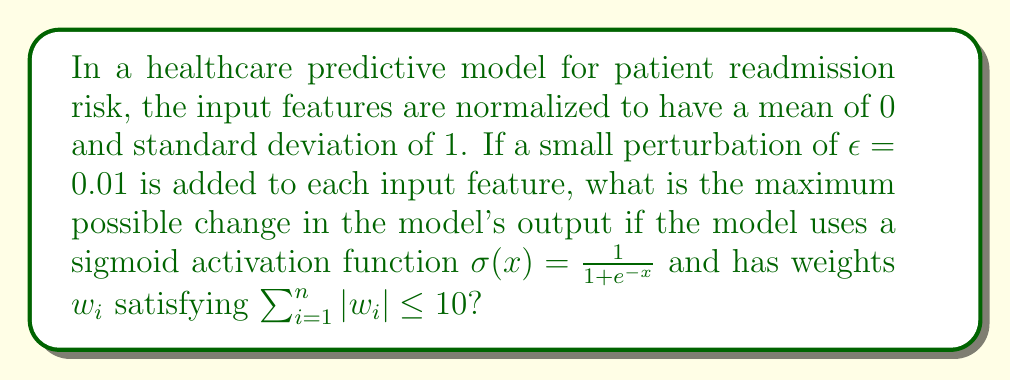Help me with this question. Let's approach this step-by-step:

1) The model's output before perturbation is:
   $$y = \sigma(\sum_{i=1}^n w_i x_i)$$

2) After perturbation, the output becomes:
   $$y' = \sigma(\sum_{i=1}^n w_i (x_i + \epsilon))$$

3) The change in the model's output is:
   $$\Delta y = |y' - y| = |\sigma(\sum_{i=1}^n w_i (x_i + \epsilon)) - \sigma(\sum_{i=1}^n w_i x_i)|$$

4) Using the mean value theorem, we can bound this change:
   $$\Delta y \leq \max_x |\sigma'(x)| \cdot |\sum_{i=1}^n w_i \epsilon|$$

5) The maximum value of the derivative of sigmoid function is 0.25:
   $$\max_x |\sigma'(x)| = \frac{1}{4}$$

6) The sum of weights is bounded:
   $$|\sum_{i=1}^n w_i \epsilon| \leq \epsilon \sum_{i=1}^n |w_i| \leq 10\epsilon$$

7) Combining these bounds:
   $$\Delta y \leq \frac{1}{4} \cdot 10\epsilon = \frac{5\epsilon}{2} = \frac{5 \cdot 0.01}{2} = 0.025$$

Therefore, the maximum possible change in the model's output is 0.025 or 2.5%.
Answer: 0.025 